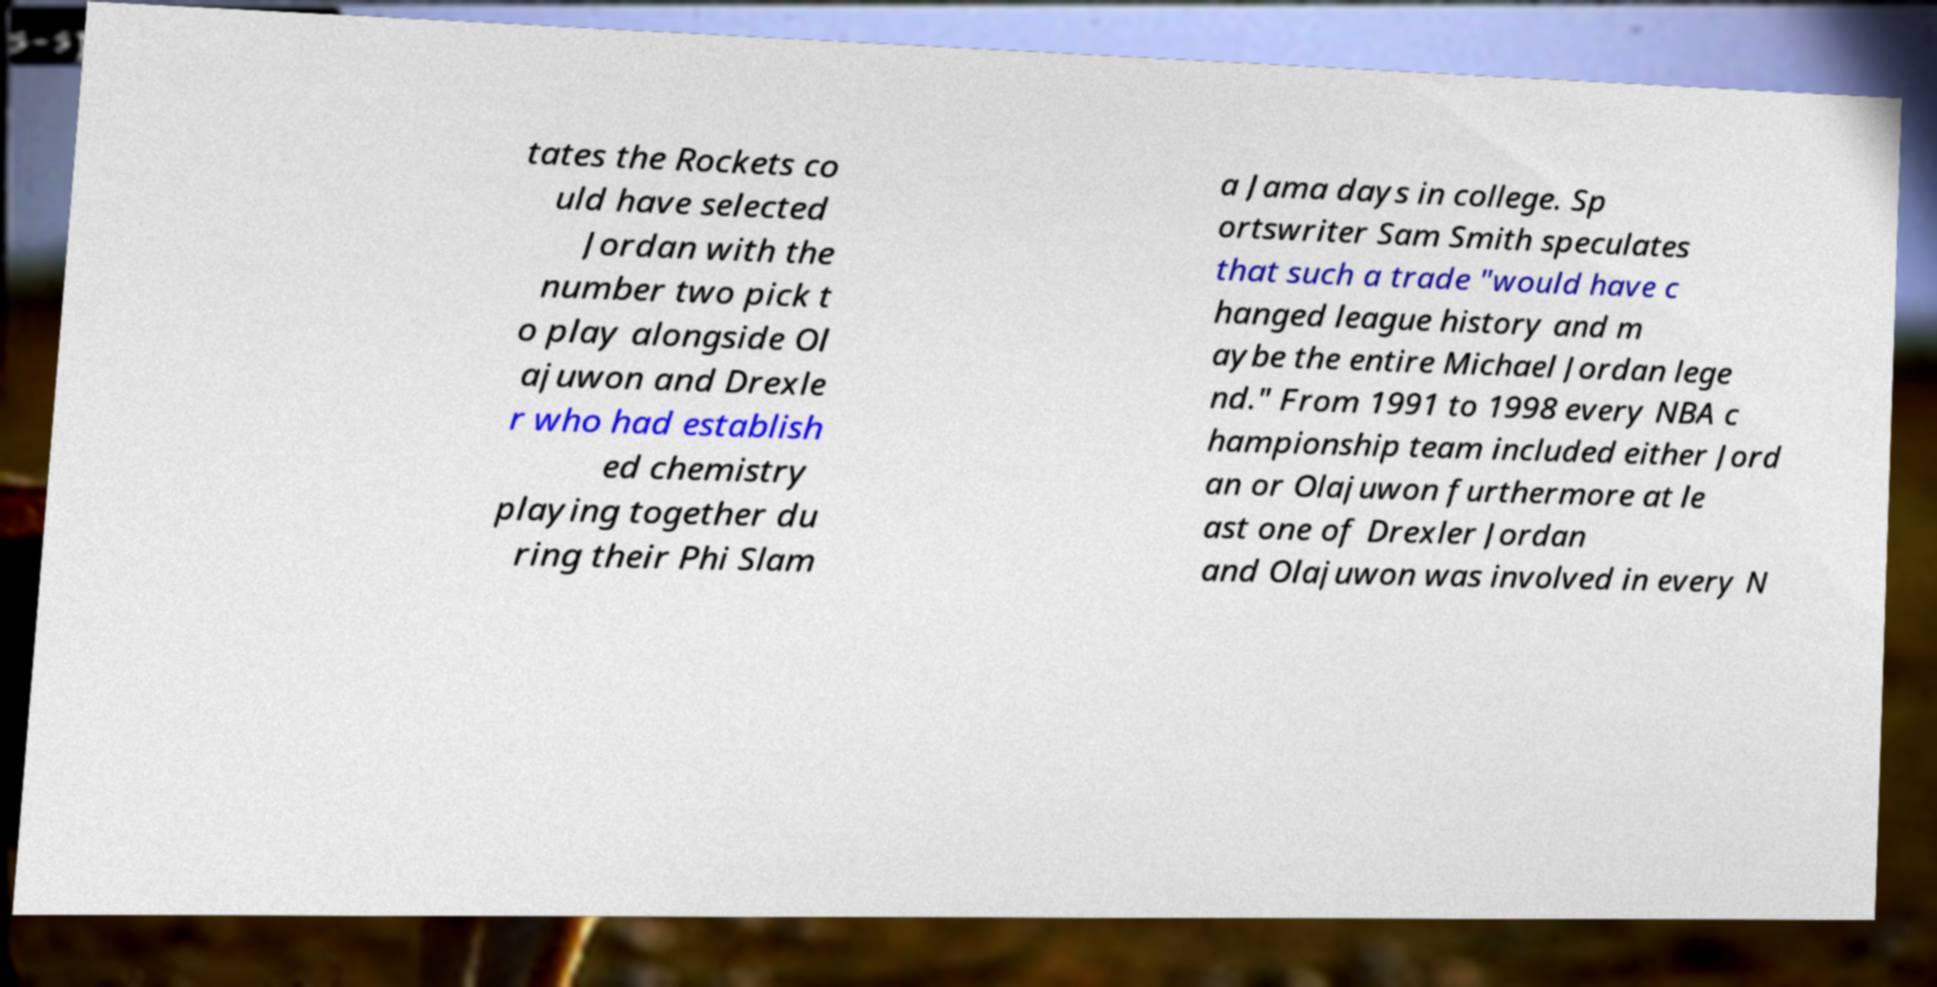Can you accurately transcribe the text from the provided image for me? tates the Rockets co uld have selected Jordan with the number two pick t o play alongside Ol ajuwon and Drexle r who had establish ed chemistry playing together du ring their Phi Slam a Jama days in college. Sp ortswriter Sam Smith speculates that such a trade "would have c hanged league history and m aybe the entire Michael Jordan lege nd." From 1991 to 1998 every NBA c hampionship team included either Jord an or Olajuwon furthermore at le ast one of Drexler Jordan and Olajuwon was involved in every N 